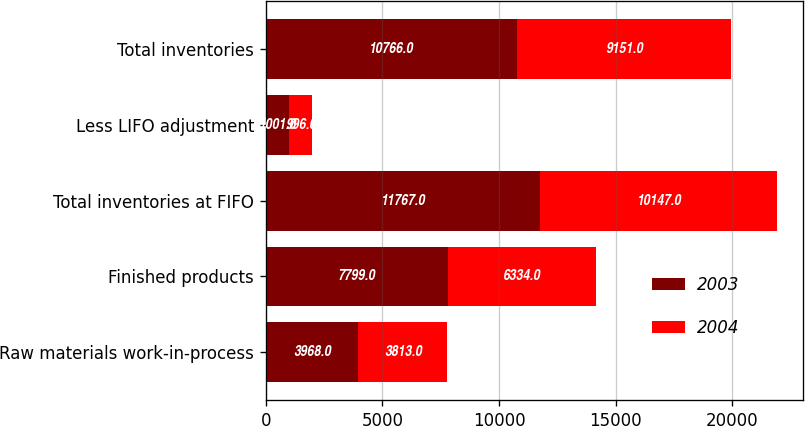Convert chart to OTSL. <chart><loc_0><loc_0><loc_500><loc_500><stacked_bar_chart><ecel><fcel>Raw materials work-in-process<fcel>Finished products<fcel>Total inventories at FIFO<fcel>Less LIFO adjustment<fcel>Total inventories<nl><fcel>2003<fcel>3968<fcel>7799<fcel>11767<fcel>1001<fcel>10766<nl><fcel>2004<fcel>3813<fcel>6334<fcel>10147<fcel>996<fcel>9151<nl></chart> 